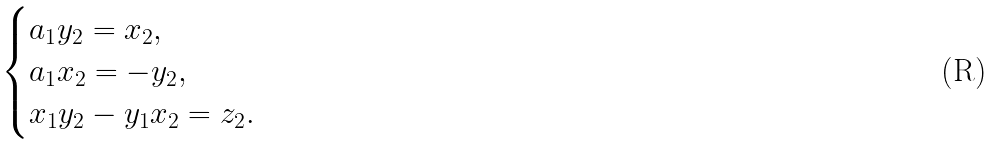<formula> <loc_0><loc_0><loc_500><loc_500>\begin{cases} a _ { 1 } y _ { 2 } = x _ { 2 } , \\ a _ { 1 } x _ { 2 } = - y _ { 2 } , \\ x _ { 1 } y _ { 2 } - y _ { 1 } x _ { 2 } = z _ { 2 } . \end{cases}</formula> 